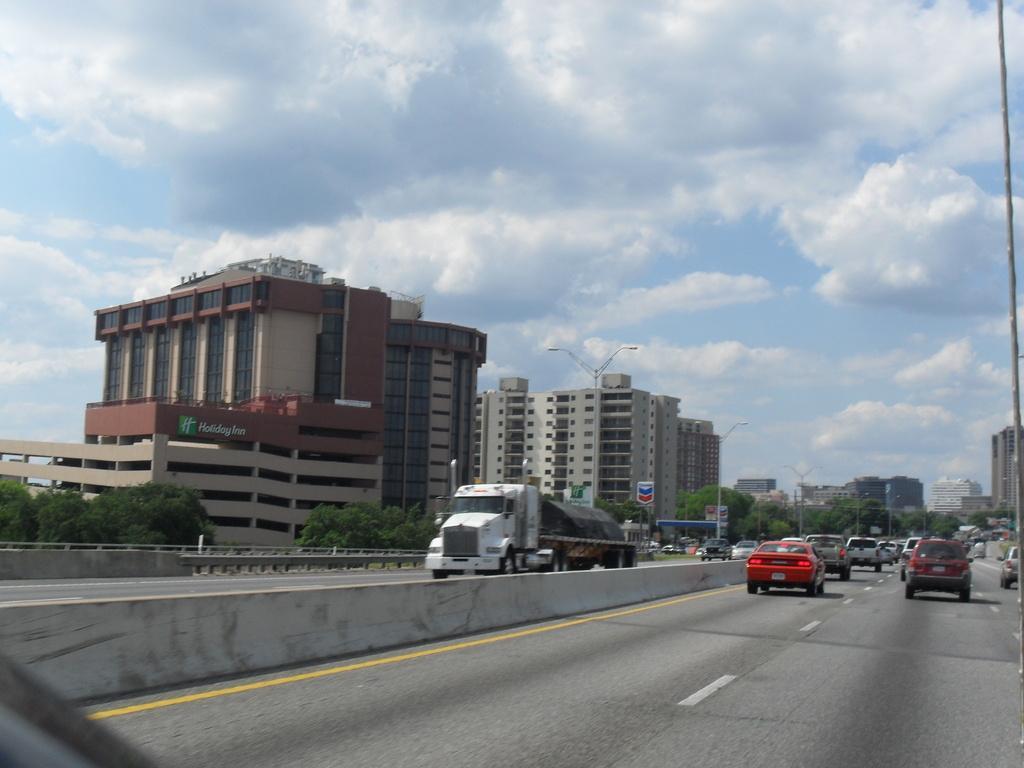How would you summarize this image in a sentence or two? On the right we can see many cars on the road. Here we can see a truck which is near to the divider. Here we can see road fencing. On the background we can see many buildings, trees, street lights and sign boards. On the top we can see sky and clouds. 